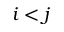<formula> <loc_0><loc_0><loc_500><loc_500>i < j</formula> 